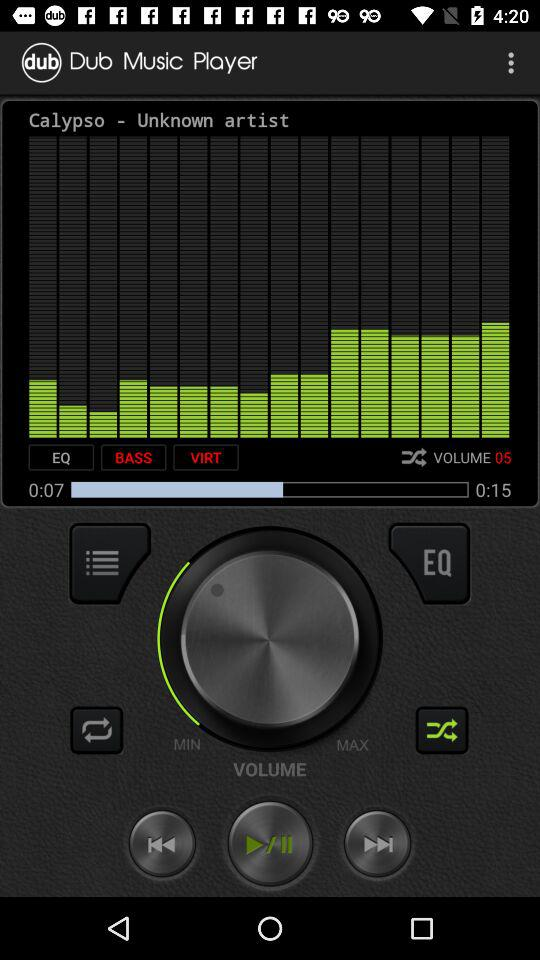How much of the audio has elapsed? There have been 7 seconds elapsed. 